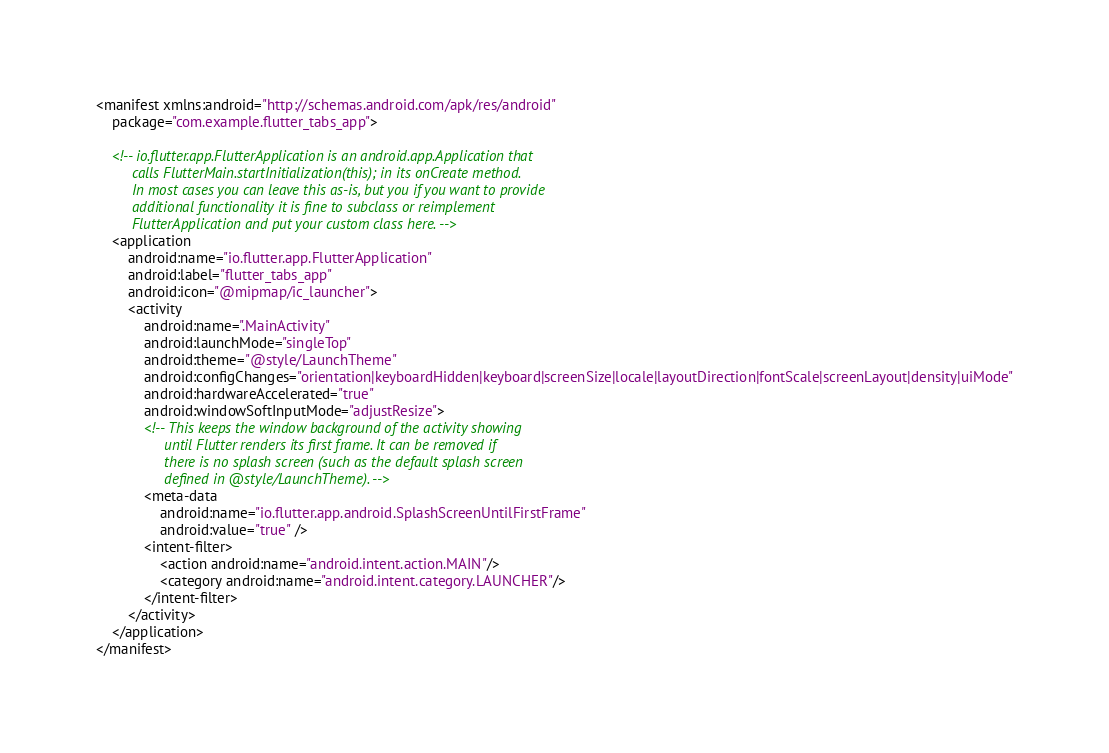<code> <loc_0><loc_0><loc_500><loc_500><_XML_><manifest xmlns:android="http://schemas.android.com/apk/res/android"
    package="com.example.flutter_tabs_app">

    <!-- io.flutter.app.FlutterApplication is an android.app.Application that
         calls FlutterMain.startInitialization(this); in its onCreate method.
         In most cases you can leave this as-is, but you if you want to provide
         additional functionality it is fine to subclass or reimplement
         FlutterApplication and put your custom class here. -->
    <application
        android:name="io.flutter.app.FlutterApplication"
        android:label="flutter_tabs_app"
        android:icon="@mipmap/ic_launcher">
        <activity
            android:name=".MainActivity"
            android:launchMode="singleTop"
            android:theme="@style/LaunchTheme"
            android:configChanges="orientation|keyboardHidden|keyboard|screenSize|locale|layoutDirection|fontScale|screenLayout|density|uiMode"
            android:hardwareAccelerated="true"
            android:windowSoftInputMode="adjustResize">
            <!-- This keeps the window background of the activity showing
                 until Flutter renders its first frame. It can be removed if
                 there is no splash screen (such as the default splash screen
                 defined in @style/LaunchTheme). -->
            <meta-data
                android:name="io.flutter.app.android.SplashScreenUntilFirstFrame"
                android:value="true" />
            <intent-filter>
                <action android:name="android.intent.action.MAIN"/>
                <category android:name="android.intent.category.LAUNCHER"/>
            </intent-filter>
        </activity>
    </application>
</manifest>
</code> 